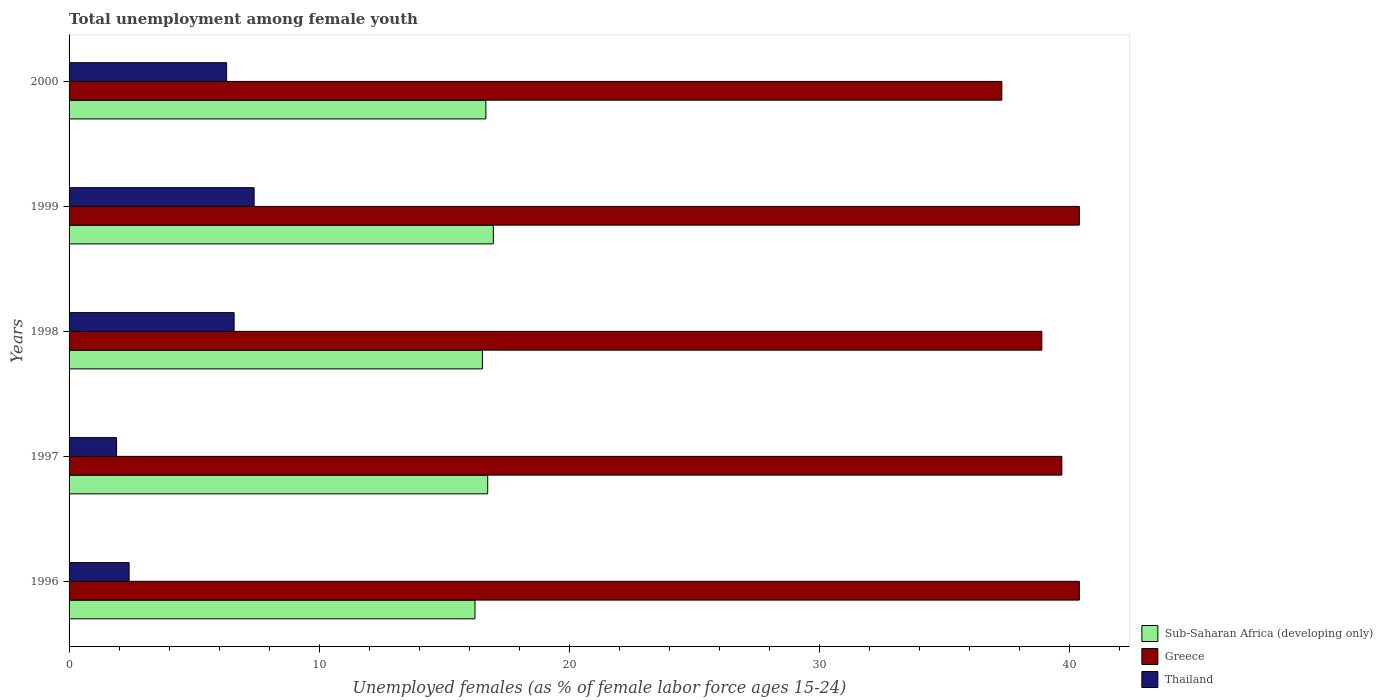How many different coloured bars are there?
Keep it short and to the point. 3. Are the number of bars per tick equal to the number of legend labels?
Your response must be concise. Yes. Are the number of bars on each tick of the Y-axis equal?
Your response must be concise. Yes. How many bars are there on the 3rd tick from the top?
Give a very brief answer. 3. What is the label of the 2nd group of bars from the top?
Your answer should be compact. 1999. What is the percentage of unemployed females in in Greece in 1997?
Ensure brevity in your answer.  39.7. Across all years, what is the maximum percentage of unemployed females in in Greece?
Your response must be concise. 40.4. Across all years, what is the minimum percentage of unemployed females in in Thailand?
Make the answer very short. 1.9. In which year was the percentage of unemployed females in in Greece minimum?
Give a very brief answer. 2000. What is the total percentage of unemployed females in in Greece in the graph?
Provide a succinct answer. 196.7. What is the difference between the percentage of unemployed females in in Sub-Saharan Africa (developing only) in 1996 and the percentage of unemployed females in in Thailand in 1998?
Offer a terse response. 9.63. What is the average percentage of unemployed females in in Thailand per year?
Your answer should be very brief. 4.92. In the year 1996, what is the difference between the percentage of unemployed females in in Greece and percentage of unemployed females in in Thailand?
Your answer should be compact. 38. In how many years, is the percentage of unemployed females in in Sub-Saharan Africa (developing only) greater than 40 %?
Your answer should be compact. 0. What is the ratio of the percentage of unemployed females in in Sub-Saharan Africa (developing only) in 1999 to that in 2000?
Ensure brevity in your answer.  1.02. What is the difference between the highest and the second highest percentage of unemployed females in in Thailand?
Offer a very short reply. 0.8. What is the difference between the highest and the lowest percentage of unemployed females in in Greece?
Make the answer very short. 3.1. In how many years, is the percentage of unemployed females in in Sub-Saharan Africa (developing only) greater than the average percentage of unemployed females in in Sub-Saharan Africa (developing only) taken over all years?
Make the answer very short. 3. Is the sum of the percentage of unemployed females in in Thailand in 1996 and 1998 greater than the maximum percentage of unemployed females in in Sub-Saharan Africa (developing only) across all years?
Provide a short and direct response. No. What does the 1st bar from the top in 1999 represents?
Keep it short and to the point. Thailand. What does the 3rd bar from the bottom in 2000 represents?
Keep it short and to the point. Thailand. Is it the case that in every year, the sum of the percentage of unemployed females in in Thailand and percentage of unemployed females in in Sub-Saharan Africa (developing only) is greater than the percentage of unemployed females in in Greece?
Provide a short and direct response. No. Are all the bars in the graph horizontal?
Your answer should be very brief. Yes. How many years are there in the graph?
Offer a terse response. 5. What is the difference between two consecutive major ticks on the X-axis?
Provide a short and direct response. 10. Are the values on the major ticks of X-axis written in scientific E-notation?
Make the answer very short. No. Does the graph contain any zero values?
Offer a very short reply. No. Does the graph contain grids?
Provide a short and direct response. No. How many legend labels are there?
Offer a very short reply. 3. How are the legend labels stacked?
Make the answer very short. Vertical. What is the title of the graph?
Your answer should be compact. Total unemployment among female youth. Does "Costa Rica" appear as one of the legend labels in the graph?
Ensure brevity in your answer.  No. What is the label or title of the X-axis?
Give a very brief answer. Unemployed females (as % of female labor force ages 15-24). What is the Unemployed females (as % of female labor force ages 15-24) of Sub-Saharan Africa (developing only) in 1996?
Keep it short and to the point. 16.23. What is the Unemployed females (as % of female labor force ages 15-24) in Greece in 1996?
Keep it short and to the point. 40.4. What is the Unemployed females (as % of female labor force ages 15-24) in Thailand in 1996?
Your response must be concise. 2.4. What is the Unemployed females (as % of female labor force ages 15-24) in Sub-Saharan Africa (developing only) in 1997?
Your answer should be very brief. 16.74. What is the Unemployed females (as % of female labor force ages 15-24) in Greece in 1997?
Provide a short and direct response. 39.7. What is the Unemployed females (as % of female labor force ages 15-24) in Thailand in 1997?
Offer a terse response. 1.9. What is the Unemployed females (as % of female labor force ages 15-24) of Sub-Saharan Africa (developing only) in 1998?
Ensure brevity in your answer.  16.53. What is the Unemployed females (as % of female labor force ages 15-24) in Greece in 1998?
Provide a succinct answer. 38.9. What is the Unemployed females (as % of female labor force ages 15-24) in Thailand in 1998?
Ensure brevity in your answer.  6.6. What is the Unemployed females (as % of female labor force ages 15-24) in Sub-Saharan Africa (developing only) in 1999?
Your response must be concise. 16.97. What is the Unemployed females (as % of female labor force ages 15-24) in Greece in 1999?
Give a very brief answer. 40.4. What is the Unemployed females (as % of female labor force ages 15-24) in Thailand in 1999?
Ensure brevity in your answer.  7.4. What is the Unemployed females (as % of female labor force ages 15-24) of Sub-Saharan Africa (developing only) in 2000?
Ensure brevity in your answer.  16.67. What is the Unemployed females (as % of female labor force ages 15-24) of Greece in 2000?
Provide a succinct answer. 37.3. What is the Unemployed females (as % of female labor force ages 15-24) in Thailand in 2000?
Provide a short and direct response. 6.3. Across all years, what is the maximum Unemployed females (as % of female labor force ages 15-24) in Sub-Saharan Africa (developing only)?
Offer a very short reply. 16.97. Across all years, what is the maximum Unemployed females (as % of female labor force ages 15-24) of Greece?
Offer a terse response. 40.4. Across all years, what is the maximum Unemployed females (as % of female labor force ages 15-24) of Thailand?
Offer a very short reply. 7.4. Across all years, what is the minimum Unemployed females (as % of female labor force ages 15-24) of Sub-Saharan Africa (developing only)?
Your answer should be very brief. 16.23. Across all years, what is the minimum Unemployed females (as % of female labor force ages 15-24) in Greece?
Offer a terse response. 37.3. Across all years, what is the minimum Unemployed females (as % of female labor force ages 15-24) in Thailand?
Your response must be concise. 1.9. What is the total Unemployed females (as % of female labor force ages 15-24) in Sub-Saharan Africa (developing only) in the graph?
Offer a very short reply. 83.14. What is the total Unemployed females (as % of female labor force ages 15-24) of Greece in the graph?
Provide a short and direct response. 196.7. What is the total Unemployed females (as % of female labor force ages 15-24) in Thailand in the graph?
Your answer should be very brief. 24.6. What is the difference between the Unemployed females (as % of female labor force ages 15-24) in Sub-Saharan Africa (developing only) in 1996 and that in 1997?
Make the answer very short. -0.51. What is the difference between the Unemployed females (as % of female labor force ages 15-24) in Thailand in 1996 and that in 1997?
Give a very brief answer. 0.5. What is the difference between the Unemployed females (as % of female labor force ages 15-24) in Sub-Saharan Africa (developing only) in 1996 and that in 1998?
Offer a terse response. -0.3. What is the difference between the Unemployed females (as % of female labor force ages 15-24) of Greece in 1996 and that in 1998?
Your answer should be very brief. 1.5. What is the difference between the Unemployed females (as % of female labor force ages 15-24) in Sub-Saharan Africa (developing only) in 1996 and that in 1999?
Provide a succinct answer. -0.73. What is the difference between the Unemployed females (as % of female labor force ages 15-24) in Greece in 1996 and that in 1999?
Make the answer very short. 0. What is the difference between the Unemployed females (as % of female labor force ages 15-24) in Thailand in 1996 and that in 1999?
Offer a terse response. -5. What is the difference between the Unemployed females (as % of female labor force ages 15-24) of Sub-Saharan Africa (developing only) in 1996 and that in 2000?
Give a very brief answer. -0.44. What is the difference between the Unemployed females (as % of female labor force ages 15-24) of Greece in 1996 and that in 2000?
Offer a terse response. 3.1. What is the difference between the Unemployed females (as % of female labor force ages 15-24) of Thailand in 1996 and that in 2000?
Your answer should be very brief. -3.9. What is the difference between the Unemployed females (as % of female labor force ages 15-24) in Sub-Saharan Africa (developing only) in 1997 and that in 1998?
Provide a short and direct response. 0.21. What is the difference between the Unemployed females (as % of female labor force ages 15-24) in Thailand in 1997 and that in 1998?
Offer a terse response. -4.7. What is the difference between the Unemployed females (as % of female labor force ages 15-24) of Sub-Saharan Africa (developing only) in 1997 and that in 1999?
Your response must be concise. -0.23. What is the difference between the Unemployed females (as % of female labor force ages 15-24) of Thailand in 1997 and that in 1999?
Ensure brevity in your answer.  -5.5. What is the difference between the Unemployed females (as % of female labor force ages 15-24) of Sub-Saharan Africa (developing only) in 1997 and that in 2000?
Make the answer very short. 0.07. What is the difference between the Unemployed females (as % of female labor force ages 15-24) in Sub-Saharan Africa (developing only) in 1998 and that in 1999?
Your response must be concise. -0.44. What is the difference between the Unemployed females (as % of female labor force ages 15-24) in Sub-Saharan Africa (developing only) in 1998 and that in 2000?
Provide a succinct answer. -0.14. What is the difference between the Unemployed females (as % of female labor force ages 15-24) in Sub-Saharan Africa (developing only) in 1999 and that in 2000?
Your answer should be very brief. 0.3. What is the difference between the Unemployed females (as % of female labor force ages 15-24) in Thailand in 1999 and that in 2000?
Provide a succinct answer. 1.1. What is the difference between the Unemployed females (as % of female labor force ages 15-24) of Sub-Saharan Africa (developing only) in 1996 and the Unemployed females (as % of female labor force ages 15-24) of Greece in 1997?
Make the answer very short. -23.47. What is the difference between the Unemployed females (as % of female labor force ages 15-24) in Sub-Saharan Africa (developing only) in 1996 and the Unemployed females (as % of female labor force ages 15-24) in Thailand in 1997?
Make the answer very short. 14.33. What is the difference between the Unemployed females (as % of female labor force ages 15-24) in Greece in 1996 and the Unemployed females (as % of female labor force ages 15-24) in Thailand in 1997?
Give a very brief answer. 38.5. What is the difference between the Unemployed females (as % of female labor force ages 15-24) in Sub-Saharan Africa (developing only) in 1996 and the Unemployed females (as % of female labor force ages 15-24) in Greece in 1998?
Your response must be concise. -22.67. What is the difference between the Unemployed females (as % of female labor force ages 15-24) in Sub-Saharan Africa (developing only) in 1996 and the Unemployed females (as % of female labor force ages 15-24) in Thailand in 1998?
Keep it short and to the point. 9.63. What is the difference between the Unemployed females (as % of female labor force ages 15-24) in Greece in 1996 and the Unemployed females (as % of female labor force ages 15-24) in Thailand in 1998?
Provide a short and direct response. 33.8. What is the difference between the Unemployed females (as % of female labor force ages 15-24) in Sub-Saharan Africa (developing only) in 1996 and the Unemployed females (as % of female labor force ages 15-24) in Greece in 1999?
Make the answer very short. -24.17. What is the difference between the Unemployed females (as % of female labor force ages 15-24) in Sub-Saharan Africa (developing only) in 1996 and the Unemployed females (as % of female labor force ages 15-24) in Thailand in 1999?
Provide a short and direct response. 8.83. What is the difference between the Unemployed females (as % of female labor force ages 15-24) of Greece in 1996 and the Unemployed females (as % of female labor force ages 15-24) of Thailand in 1999?
Your answer should be very brief. 33. What is the difference between the Unemployed females (as % of female labor force ages 15-24) of Sub-Saharan Africa (developing only) in 1996 and the Unemployed females (as % of female labor force ages 15-24) of Greece in 2000?
Provide a short and direct response. -21.07. What is the difference between the Unemployed females (as % of female labor force ages 15-24) in Sub-Saharan Africa (developing only) in 1996 and the Unemployed females (as % of female labor force ages 15-24) in Thailand in 2000?
Keep it short and to the point. 9.93. What is the difference between the Unemployed females (as % of female labor force ages 15-24) of Greece in 1996 and the Unemployed females (as % of female labor force ages 15-24) of Thailand in 2000?
Make the answer very short. 34.1. What is the difference between the Unemployed females (as % of female labor force ages 15-24) in Sub-Saharan Africa (developing only) in 1997 and the Unemployed females (as % of female labor force ages 15-24) in Greece in 1998?
Provide a succinct answer. -22.16. What is the difference between the Unemployed females (as % of female labor force ages 15-24) in Sub-Saharan Africa (developing only) in 1997 and the Unemployed females (as % of female labor force ages 15-24) in Thailand in 1998?
Your answer should be very brief. 10.14. What is the difference between the Unemployed females (as % of female labor force ages 15-24) of Greece in 1997 and the Unemployed females (as % of female labor force ages 15-24) of Thailand in 1998?
Offer a terse response. 33.1. What is the difference between the Unemployed females (as % of female labor force ages 15-24) of Sub-Saharan Africa (developing only) in 1997 and the Unemployed females (as % of female labor force ages 15-24) of Greece in 1999?
Give a very brief answer. -23.66. What is the difference between the Unemployed females (as % of female labor force ages 15-24) of Sub-Saharan Africa (developing only) in 1997 and the Unemployed females (as % of female labor force ages 15-24) of Thailand in 1999?
Your response must be concise. 9.34. What is the difference between the Unemployed females (as % of female labor force ages 15-24) of Greece in 1997 and the Unemployed females (as % of female labor force ages 15-24) of Thailand in 1999?
Keep it short and to the point. 32.3. What is the difference between the Unemployed females (as % of female labor force ages 15-24) in Sub-Saharan Africa (developing only) in 1997 and the Unemployed females (as % of female labor force ages 15-24) in Greece in 2000?
Provide a short and direct response. -20.56. What is the difference between the Unemployed females (as % of female labor force ages 15-24) in Sub-Saharan Africa (developing only) in 1997 and the Unemployed females (as % of female labor force ages 15-24) in Thailand in 2000?
Offer a terse response. 10.44. What is the difference between the Unemployed females (as % of female labor force ages 15-24) of Greece in 1997 and the Unemployed females (as % of female labor force ages 15-24) of Thailand in 2000?
Provide a short and direct response. 33.4. What is the difference between the Unemployed females (as % of female labor force ages 15-24) of Sub-Saharan Africa (developing only) in 1998 and the Unemployed females (as % of female labor force ages 15-24) of Greece in 1999?
Provide a short and direct response. -23.87. What is the difference between the Unemployed females (as % of female labor force ages 15-24) in Sub-Saharan Africa (developing only) in 1998 and the Unemployed females (as % of female labor force ages 15-24) in Thailand in 1999?
Ensure brevity in your answer.  9.13. What is the difference between the Unemployed females (as % of female labor force ages 15-24) of Greece in 1998 and the Unemployed females (as % of female labor force ages 15-24) of Thailand in 1999?
Your response must be concise. 31.5. What is the difference between the Unemployed females (as % of female labor force ages 15-24) in Sub-Saharan Africa (developing only) in 1998 and the Unemployed females (as % of female labor force ages 15-24) in Greece in 2000?
Ensure brevity in your answer.  -20.77. What is the difference between the Unemployed females (as % of female labor force ages 15-24) in Sub-Saharan Africa (developing only) in 1998 and the Unemployed females (as % of female labor force ages 15-24) in Thailand in 2000?
Provide a succinct answer. 10.23. What is the difference between the Unemployed females (as % of female labor force ages 15-24) in Greece in 1998 and the Unemployed females (as % of female labor force ages 15-24) in Thailand in 2000?
Make the answer very short. 32.6. What is the difference between the Unemployed females (as % of female labor force ages 15-24) of Sub-Saharan Africa (developing only) in 1999 and the Unemployed females (as % of female labor force ages 15-24) of Greece in 2000?
Provide a succinct answer. -20.33. What is the difference between the Unemployed females (as % of female labor force ages 15-24) in Sub-Saharan Africa (developing only) in 1999 and the Unemployed females (as % of female labor force ages 15-24) in Thailand in 2000?
Your response must be concise. 10.67. What is the difference between the Unemployed females (as % of female labor force ages 15-24) in Greece in 1999 and the Unemployed females (as % of female labor force ages 15-24) in Thailand in 2000?
Offer a very short reply. 34.1. What is the average Unemployed females (as % of female labor force ages 15-24) of Sub-Saharan Africa (developing only) per year?
Provide a short and direct response. 16.63. What is the average Unemployed females (as % of female labor force ages 15-24) in Greece per year?
Keep it short and to the point. 39.34. What is the average Unemployed females (as % of female labor force ages 15-24) of Thailand per year?
Your answer should be very brief. 4.92. In the year 1996, what is the difference between the Unemployed females (as % of female labor force ages 15-24) in Sub-Saharan Africa (developing only) and Unemployed females (as % of female labor force ages 15-24) in Greece?
Offer a very short reply. -24.17. In the year 1996, what is the difference between the Unemployed females (as % of female labor force ages 15-24) in Sub-Saharan Africa (developing only) and Unemployed females (as % of female labor force ages 15-24) in Thailand?
Provide a succinct answer. 13.83. In the year 1997, what is the difference between the Unemployed females (as % of female labor force ages 15-24) of Sub-Saharan Africa (developing only) and Unemployed females (as % of female labor force ages 15-24) of Greece?
Your answer should be compact. -22.96. In the year 1997, what is the difference between the Unemployed females (as % of female labor force ages 15-24) of Sub-Saharan Africa (developing only) and Unemployed females (as % of female labor force ages 15-24) of Thailand?
Ensure brevity in your answer.  14.84. In the year 1997, what is the difference between the Unemployed females (as % of female labor force ages 15-24) of Greece and Unemployed females (as % of female labor force ages 15-24) of Thailand?
Offer a very short reply. 37.8. In the year 1998, what is the difference between the Unemployed females (as % of female labor force ages 15-24) in Sub-Saharan Africa (developing only) and Unemployed females (as % of female labor force ages 15-24) in Greece?
Your answer should be compact. -22.37. In the year 1998, what is the difference between the Unemployed females (as % of female labor force ages 15-24) in Sub-Saharan Africa (developing only) and Unemployed females (as % of female labor force ages 15-24) in Thailand?
Keep it short and to the point. 9.93. In the year 1998, what is the difference between the Unemployed females (as % of female labor force ages 15-24) in Greece and Unemployed females (as % of female labor force ages 15-24) in Thailand?
Provide a short and direct response. 32.3. In the year 1999, what is the difference between the Unemployed females (as % of female labor force ages 15-24) in Sub-Saharan Africa (developing only) and Unemployed females (as % of female labor force ages 15-24) in Greece?
Provide a succinct answer. -23.43. In the year 1999, what is the difference between the Unemployed females (as % of female labor force ages 15-24) of Sub-Saharan Africa (developing only) and Unemployed females (as % of female labor force ages 15-24) of Thailand?
Make the answer very short. 9.57. In the year 2000, what is the difference between the Unemployed females (as % of female labor force ages 15-24) of Sub-Saharan Africa (developing only) and Unemployed females (as % of female labor force ages 15-24) of Greece?
Your answer should be very brief. -20.63. In the year 2000, what is the difference between the Unemployed females (as % of female labor force ages 15-24) of Sub-Saharan Africa (developing only) and Unemployed females (as % of female labor force ages 15-24) of Thailand?
Offer a very short reply. 10.37. What is the ratio of the Unemployed females (as % of female labor force ages 15-24) in Sub-Saharan Africa (developing only) in 1996 to that in 1997?
Keep it short and to the point. 0.97. What is the ratio of the Unemployed females (as % of female labor force ages 15-24) of Greece in 1996 to that in 1997?
Ensure brevity in your answer.  1.02. What is the ratio of the Unemployed females (as % of female labor force ages 15-24) in Thailand in 1996 to that in 1997?
Give a very brief answer. 1.26. What is the ratio of the Unemployed females (as % of female labor force ages 15-24) of Sub-Saharan Africa (developing only) in 1996 to that in 1998?
Give a very brief answer. 0.98. What is the ratio of the Unemployed females (as % of female labor force ages 15-24) in Greece in 1996 to that in 1998?
Provide a short and direct response. 1.04. What is the ratio of the Unemployed females (as % of female labor force ages 15-24) of Thailand in 1996 to that in 1998?
Your answer should be compact. 0.36. What is the ratio of the Unemployed females (as % of female labor force ages 15-24) in Sub-Saharan Africa (developing only) in 1996 to that in 1999?
Your response must be concise. 0.96. What is the ratio of the Unemployed females (as % of female labor force ages 15-24) in Greece in 1996 to that in 1999?
Offer a very short reply. 1. What is the ratio of the Unemployed females (as % of female labor force ages 15-24) of Thailand in 1996 to that in 1999?
Your answer should be very brief. 0.32. What is the ratio of the Unemployed females (as % of female labor force ages 15-24) in Sub-Saharan Africa (developing only) in 1996 to that in 2000?
Provide a succinct answer. 0.97. What is the ratio of the Unemployed females (as % of female labor force ages 15-24) in Greece in 1996 to that in 2000?
Offer a very short reply. 1.08. What is the ratio of the Unemployed females (as % of female labor force ages 15-24) in Thailand in 1996 to that in 2000?
Offer a very short reply. 0.38. What is the ratio of the Unemployed females (as % of female labor force ages 15-24) in Sub-Saharan Africa (developing only) in 1997 to that in 1998?
Your answer should be very brief. 1.01. What is the ratio of the Unemployed females (as % of female labor force ages 15-24) of Greece in 1997 to that in 1998?
Ensure brevity in your answer.  1.02. What is the ratio of the Unemployed females (as % of female labor force ages 15-24) of Thailand in 1997 to that in 1998?
Provide a succinct answer. 0.29. What is the ratio of the Unemployed females (as % of female labor force ages 15-24) of Sub-Saharan Africa (developing only) in 1997 to that in 1999?
Offer a very short reply. 0.99. What is the ratio of the Unemployed females (as % of female labor force ages 15-24) of Greece in 1997 to that in 1999?
Provide a succinct answer. 0.98. What is the ratio of the Unemployed females (as % of female labor force ages 15-24) of Thailand in 1997 to that in 1999?
Your response must be concise. 0.26. What is the ratio of the Unemployed females (as % of female labor force ages 15-24) in Sub-Saharan Africa (developing only) in 1997 to that in 2000?
Your answer should be very brief. 1. What is the ratio of the Unemployed females (as % of female labor force ages 15-24) in Greece in 1997 to that in 2000?
Give a very brief answer. 1.06. What is the ratio of the Unemployed females (as % of female labor force ages 15-24) of Thailand in 1997 to that in 2000?
Give a very brief answer. 0.3. What is the ratio of the Unemployed females (as % of female labor force ages 15-24) in Sub-Saharan Africa (developing only) in 1998 to that in 1999?
Provide a short and direct response. 0.97. What is the ratio of the Unemployed females (as % of female labor force ages 15-24) of Greece in 1998 to that in 1999?
Ensure brevity in your answer.  0.96. What is the ratio of the Unemployed females (as % of female labor force ages 15-24) in Thailand in 1998 to that in 1999?
Offer a terse response. 0.89. What is the ratio of the Unemployed females (as % of female labor force ages 15-24) in Greece in 1998 to that in 2000?
Give a very brief answer. 1.04. What is the ratio of the Unemployed females (as % of female labor force ages 15-24) in Thailand in 1998 to that in 2000?
Give a very brief answer. 1.05. What is the ratio of the Unemployed females (as % of female labor force ages 15-24) in Sub-Saharan Africa (developing only) in 1999 to that in 2000?
Give a very brief answer. 1.02. What is the ratio of the Unemployed females (as % of female labor force ages 15-24) of Greece in 1999 to that in 2000?
Make the answer very short. 1.08. What is the ratio of the Unemployed females (as % of female labor force ages 15-24) of Thailand in 1999 to that in 2000?
Provide a succinct answer. 1.17. What is the difference between the highest and the second highest Unemployed females (as % of female labor force ages 15-24) in Sub-Saharan Africa (developing only)?
Your answer should be compact. 0.23. What is the difference between the highest and the second highest Unemployed females (as % of female labor force ages 15-24) in Greece?
Keep it short and to the point. 0. What is the difference between the highest and the lowest Unemployed females (as % of female labor force ages 15-24) in Sub-Saharan Africa (developing only)?
Give a very brief answer. 0.73. What is the difference between the highest and the lowest Unemployed females (as % of female labor force ages 15-24) in Greece?
Make the answer very short. 3.1. 